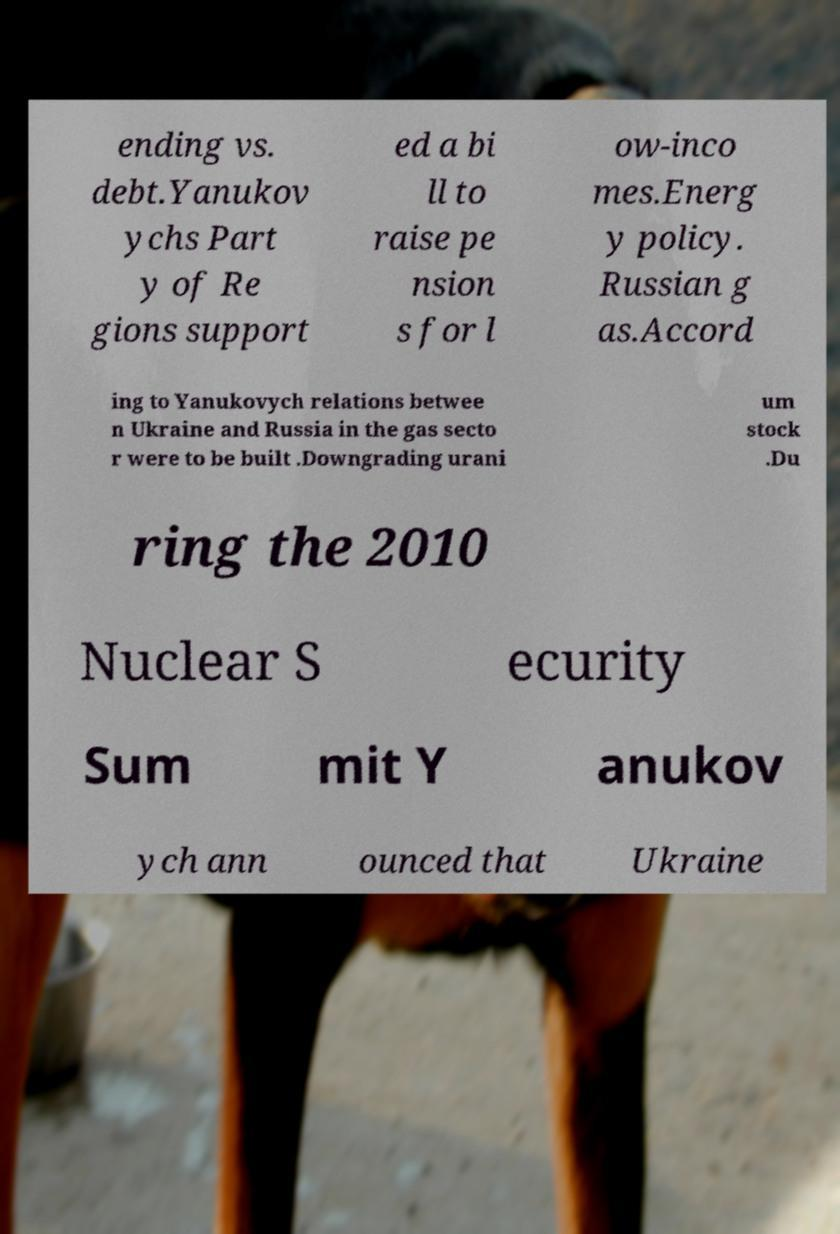Can you accurately transcribe the text from the provided image for me? ending vs. debt.Yanukov ychs Part y of Re gions support ed a bi ll to raise pe nsion s for l ow-inco mes.Energ y policy. Russian g as.Accord ing to Yanukovych relations betwee n Ukraine and Russia in the gas secto r were to be built .Downgrading urani um stock .Du ring the 2010 Nuclear S ecurity Sum mit Y anukov ych ann ounced that Ukraine 